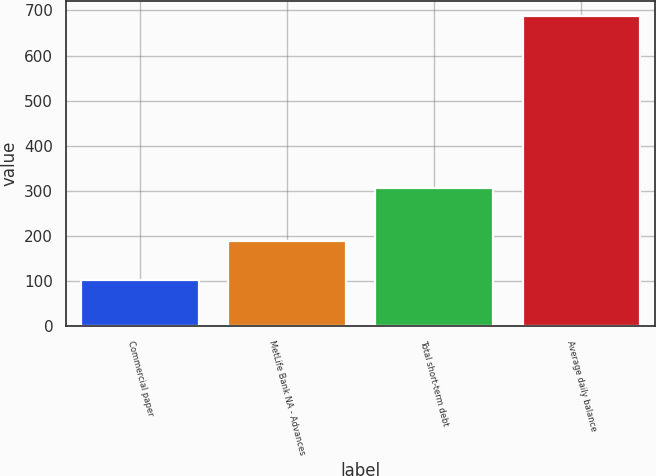Convert chart to OTSL. <chart><loc_0><loc_0><loc_500><loc_500><bar_chart><fcel>Commercial paper<fcel>MetLife Bank NA - Advances<fcel>Total short-term debt<fcel>Average daily balance<nl><fcel>102<fcel>190<fcel>306<fcel>687<nl></chart> 